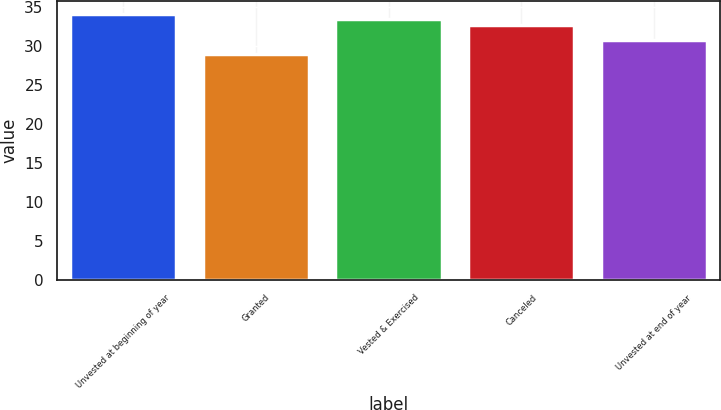<chart> <loc_0><loc_0><loc_500><loc_500><bar_chart><fcel>Unvested at beginning of year<fcel>Granted<fcel>Vested & Exercised<fcel>Canceled<fcel>Unvested at end of year<nl><fcel>34.04<fcel>28.9<fcel>33.4<fcel>32.7<fcel>30.76<nl></chart> 